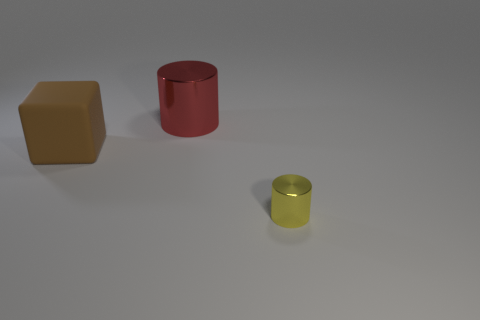Add 1 yellow objects. How many objects exist? 4 Subtract all cylinders. How many objects are left? 1 Add 3 large brown matte cubes. How many large brown matte cubes are left? 4 Add 3 yellow objects. How many yellow objects exist? 4 Subtract 0 brown spheres. How many objects are left? 3 Subtract all small yellow cylinders. Subtract all small yellow metal things. How many objects are left? 1 